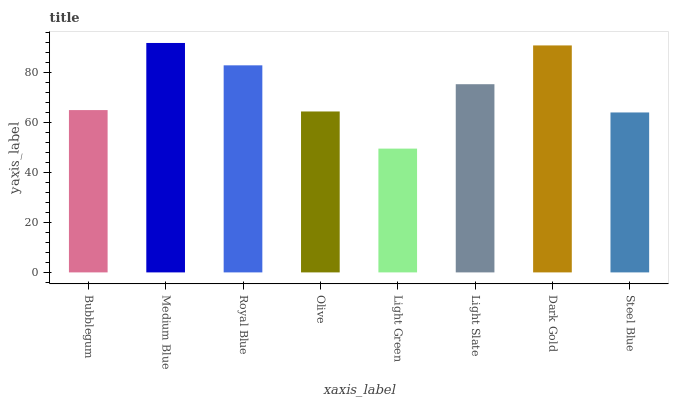Is Light Green the minimum?
Answer yes or no. Yes. Is Medium Blue the maximum?
Answer yes or no. Yes. Is Royal Blue the minimum?
Answer yes or no. No. Is Royal Blue the maximum?
Answer yes or no. No. Is Medium Blue greater than Royal Blue?
Answer yes or no. Yes. Is Royal Blue less than Medium Blue?
Answer yes or no. Yes. Is Royal Blue greater than Medium Blue?
Answer yes or no. No. Is Medium Blue less than Royal Blue?
Answer yes or no. No. Is Light Slate the high median?
Answer yes or no. Yes. Is Bubblegum the low median?
Answer yes or no. Yes. Is Medium Blue the high median?
Answer yes or no. No. Is Dark Gold the low median?
Answer yes or no. No. 